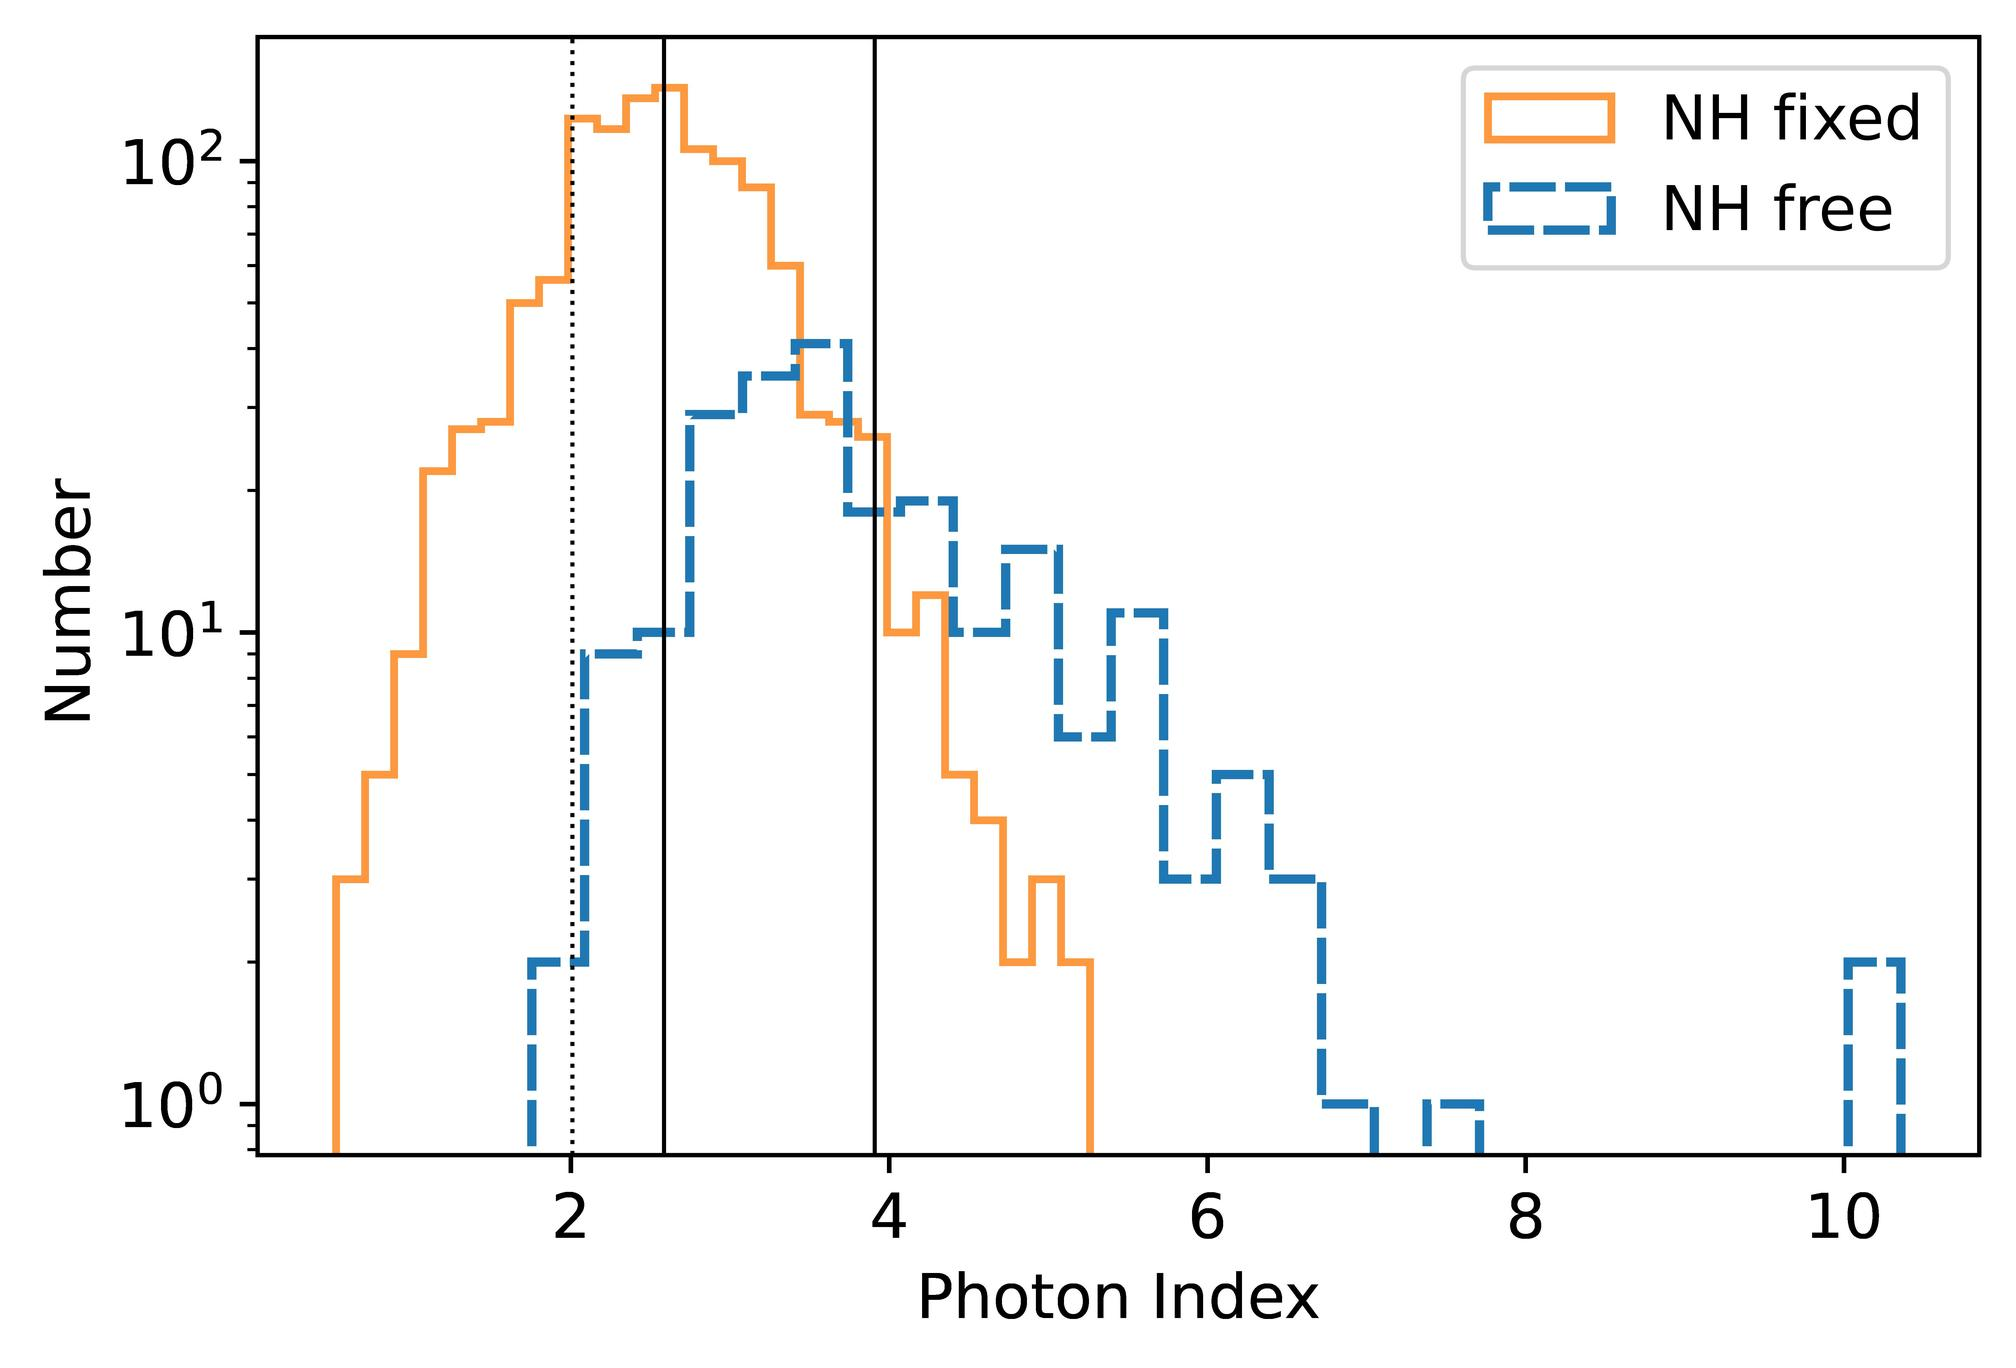At which photon index value does the distribution for NH fixed peak? In the provided histogram, the peak for the NH fixed distribution, which is represented by the solid orange line, occurs around a photon index of 3.0. This suggests a concentration or preference in the occurrence of whatever data the NH fixed represents at this index, compared to others. Understanding these peaks can provide insights into the underlying physics or astronomical phenomena being studied, potentially indicating prevalent conditions or typical behaviors. 